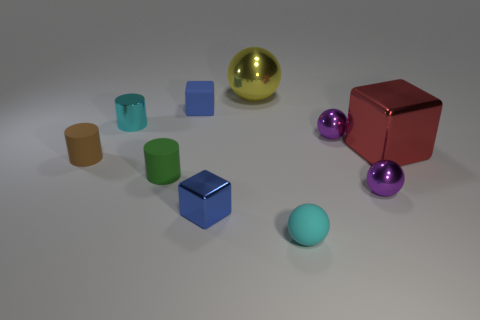Subtract all metallic balls. How many balls are left? 1 Subtract all purple blocks. How many purple balls are left? 2 Subtract 1 cylinders. How many cylinders are left? 2 Subtract all yellow spheres. How many spheres are left? 3 Subtract 1 purple balls. How many objects are left? 9 Subtract all cubes. How many objects are left? 7 Subtract all cyan blocks. Subtract all green spheres. How many blocks are left? 3 Subtract all red metallic objects. Subtract all large blue rubber spheres. How many objects are left? 9 Add 2 small blue matte objects. How many small blue matte objects are left? 3 Add 2 large red blocks. How many large red blocks exist? 3 